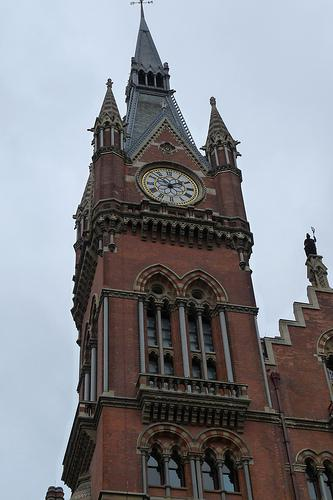Question: what at the top of the tower?
Choices:
A. A balcony.
B. A clock.
C. Restaurant.
D. Lights.
Answer with the letter. Answer: B Question: what time is it?
Choices:
A. Noon.
B. Almost two.
C. Midnight.
D. Five.
Answer with the letter. Answer: B Question: why are there reflections?
Choices:
A. There are mirros.
B. There is metal.
C. There is water.
D. There are glass windows.
Answer with the letter. Answer: D Question: what color is the sky?
Choices:
A. Blue.
B. Orange.
C. Purple.
D. Grey.
Answer with the letter. Answer: D Question: what color is the clock's trim?
Choices:
A. Gold.
B. Black.
C. Yellow.
D. White.
Answer with the letter. Answer: A 